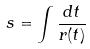<formula> <loc_0><loc_0><loc_500><loc_500>s = \int \frac { d t } { r ( t ) }</formula> 